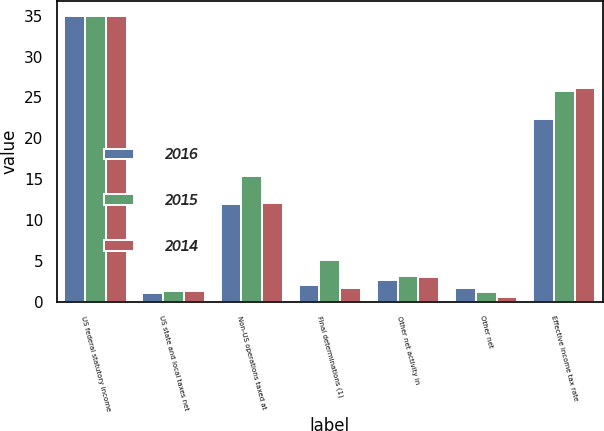<chart> <loc_0><loc_0><loc_500><loc_500><stacked_bar_chart><ecel><fcel>US federal statutory income<fcel>US state and local taxes net<fcel>Non-US operations taxed at<fcel>Final determinations (1)<fcel>Other net activity in<fcel>Other net<fcel>Effective income tax rate<nl><fcel>2016<fcel>35<fcel>1.1<fcel>12<fcel>2.1<fcel>2.7<fcel>1.7<fcel>22.4<nl><fcel>2015<fcel>35<fcel>1.3<fcel>15.4<fcel>5.1<fcel>3.2<fcel>1.2<fcel>25.8<nl><fcel>2014<fcel>35<fcel>1.3<fcel>12.1<fcel>1.7<fcel>3<fcel>0.6<fcel>26.1<nl></chart> 